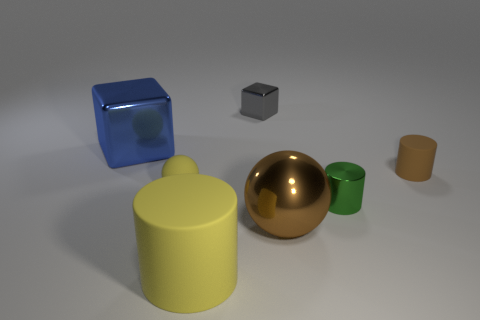Add 1 large blue blocks. How many objects exist? 8 Subtract all cylinders. How many objects are left? 4 Add 7 gray metal balls. How many gray metal balls exist? 7 Subtract 1 yellow cylinders. How many objects are left? 6 Subtract all tiny cyan shiny balls. Subtract all small gray blocks. How many objects are left? 6 Add 5 small gray things. How many small gray things are left? 6 